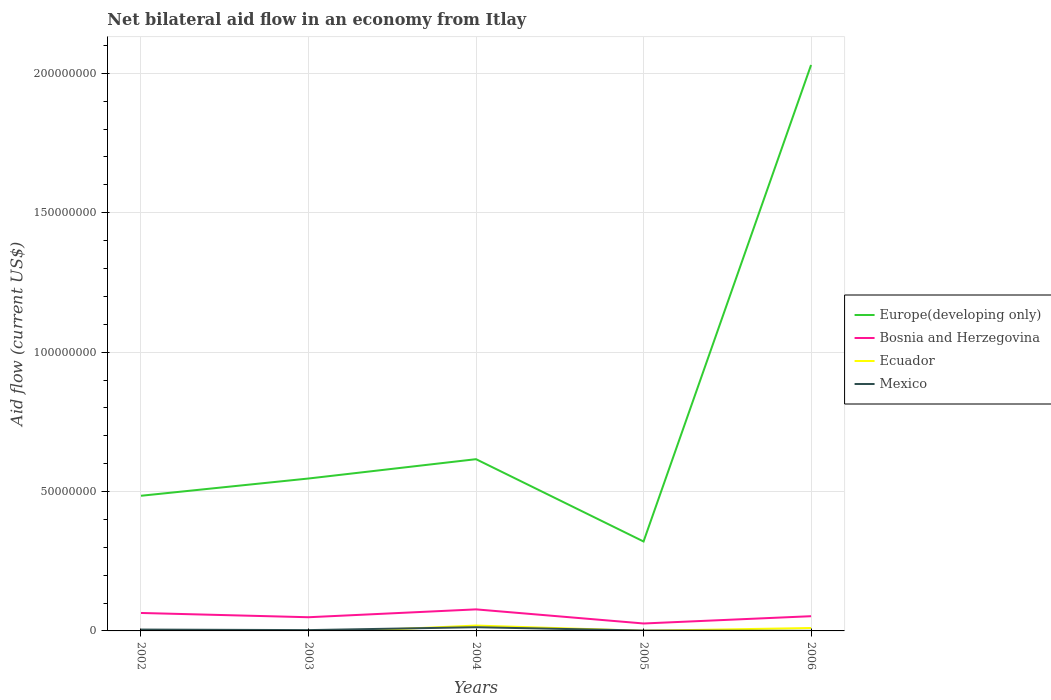How many different coloured lines are there?
Offer a terse response. 4. Is the number of lines equal to the number of legend labels?
Give a very brief answer. No. Across all years, what is the maximum net bilateral aid flow in Mexico?
Ensure brevity in your answer.  2.00e+04. What is the total net bilateral aid flow in Bosnia and Herzegovina in the graph?
Offer a very short reply. 2.24e+06. What is the difference between the highest and the second highest net bilateral aid flow in Europe(developing only)?
Ensure brevity in your answer.  1.71e+08. What is the difference between the highest and the lowest net bilateral aid flow in Bosnia and Herzegovina?
Your response must be concise. 2. Are the values on the major ticks of Y-axis written in scientific E-notation?
Give a very brief answer. No. Where does the legend appear in the graph?
Your answer should be very brief. Center right. What is the title of the graph?
Offer a terse response. Net bilateral aid flow in an economy from Itlay. Does "European Union" appear as one of the legend labels in the graph?
Make the answer very short. No. What is the Aid flow (current US$) of Europe(developing only) in 2002?
Provide a short and direct response. 4.85e+07. What is the Aid flow (current US$) in Bosnia and Herzegovina in 2002?
Keep it short and to the point. 6.44e+06. What is the Aid flow (current US$) of Ecuador in 2002?
Offer a very short reply. 3.20e+05. What is the Aid flow (current US$) of Europe(developing only) in 2003?
Keep it short and to the point. 5.47e+07. What is the Aid flow (current US$) of Bosnia and Herzegovina in 2003?
Make the answer very short. 4.91e+06. What is the Aid flow (current US$) of Ecuador in 2003?
Offer a terse response. 0. What is the Aid flow (current US$) of Europe(developing only) in 2004?
Your answer should be compact. 6.16e+07. What is the Aid flow (current US$) in Bosnia and Herzegovina in 2004?
Offer a terse response. 7.73e+06. What is the Aid flow (current US$) in Ecuador in 2004?
Offer a very short reply. 1.93e+06. What is the Aid flow (current US$) in Mexico in 2004?
Your answer should be very brief. 1.33e+06. What is the Aid flow (current US$) of Europe(developing only) in 2005?
Ensure brevity in your answer.  3.21e+07. What is the Aid flow (current US$) of Bosnia and Herzegovina in 2005?
Your answer should be very brief. 2.67e+06. What is the Aid flow (current US$) in Ecuador in 2005?
Ensure brevity in your answer.  5.00e+04. What is the Aid flow (current US$) of Europe(developing only) in 2006?
Ensure brevity in your answer.  2.03e+08. What is the Aid flow (current US$) of Bosnia and Herzegovina in 2006?
Ensure brevity in your answer.  5.28e+06. What is the Aid flow (current US$) of Ecuador in 2006?
Provide a short and direct response. 1.05e+06. What is the Aid flow (current US$) of Mexico in 2006?
Your answer should be very brief. 2.00e+04. Across all years, what is the maximum Aid flow (current US$) in Europe(developing only)?
Make the answer very short. 2.03e+08. Across all years, what is the maximum Aid flow (current US$) in Bosnia and Herzegovina?
Make the answer very short. 7.73e+06. Across all years, what is the maximum Aid flow (current US$) of Ecuador?
Offer a very short reply. 1.93e+06. Across all years, what is the maximum Aid flow (current US$) in Mexico?
Your response must be concise. 1.33e+06. Across all years, what is the minimum Aid flow (current US$) of Europe(developing only)?
Make the answer very short. 3.21e+07. Across all years, what is the minimum Aid flow (current US$) in Bosnia and Herzegovina?
Give a very brief answer. 2.67e+06. What is the total Aid flow (current US$) of Europe(developing only) in the graph?
Keep it short and to the point. 4.00e+08. What is the total Aid flow (current US$) of Bosnia and Herzegovina in the graph?
Make the answer very short. 2.70e+07. What is the total Aid flow (current US$) in Ecuador in the graph?
Keep it short and to the point. 3.35e+06. What is the total Aid flow (current US$) in Mexico in the graph?
Your answer should be very brief. 2.27e+06. What is the difference between the Aid flow (current US$) of Europe(developing only) in 2002 and that in 2003?
Keep it short and to the point. -6.19e+06. What is the difference between the Aid flow (current US$) of Bosnia and Herzegovina in 2002 and that in 2003?
Provide a short and direct response. 1.53e+06. What is the difference between the Aid flow (current US$) in Europe(developing only) in 2002 and that in 2004?
Your response must be concise. -1.31e+07. What is the difference between the Aid flow (current US$) of Bosnia and Herzegovina in 2002 and that in 2004?
Offer a very short reply. -1.29e+06. What is the difference between the Aid flow (current US$) in Ecuador in 2002 and that in 2004?
Your answer should be very brief. -1.61e+06. What is the difference between the Aid flow (current US$) in Mexico in 2002 and that in 2004?
Give a very brief answer. -8.40e+05. What is the difference between the Aid flow (current US$) in Europe(developing only) in 2002 and that in 2005?
Offer a very short reply. 1.64e+07. What is the difference between the Aid flow (current US$) of Bosnia and Herzegovina in 2002 and that in 2005?
Your answer should be very brief. 3.77e+06. What is the difference between the Aid flow (current US$) of Mexico in 2002 and that in 2005?
Your answer should be very brief. 3.50e+05. What is the difference between the Aid flow (current US$) of Europe(developing only) in 2002 and that in 2006?
Ensure brevity in your answer.  -1.55e+08. What is the difference between the Aid flow (current US$) of Bosnia and Herzegovina in 2002 and that in 2006?
Offer a very short reply. 1.16e+06. What is the difference between the Aid flow (current US$) in Ecuador in 2002 and that in 2006?
Make the answer very short. -7.30e+05. What is the difference between the Aid flow (current US$) of Mexico in 2002 and that in 2006?
Your answer should be compact. 4.70e+05. What is the difference between the Aid flow (current US$) in Europe(developing only) in 2003 and that in 2004?
Provide a succinct answer. -6.93e+06. What is the difference between the Aid flow (current US$) in Bosnia and Herzegovina in 2003 and that in 2004?
Provide a short and direct response. -2.82e+06. What is the difference between the Aid flow (current US$) in Mexico in 2003 and that in 2004?
Keep it short and to the point. -1.04e+06. What is the difference between the Aid flow (current US$) of Europe(developing only) in 2003 and that in 2005?
Provide a short and direct response. 2.26e+07. What is the difference between the Aid flow (current US$) in Bosnia and Herzegovina in 2003 and that in 2005?
Offer a terse response. 2.24e+06. What is the difference between the Aid flow (current US$) of Mexico in 2003 and that in 2005?
Keep it short and to the point. 1.50e+05. What is the difference between the Aid flow (current US$) in Europe(developing only) in 2003 and that in 2006?
Offer a terse response. -1.48e+08. What is the difference between the Aid flow (current US$) in Bosnia and Herzegovina in 2003 and that in 2006?
Give a very brief answer. -3.70e+05. What is the difference between the Aid flow (current US$) of Europe(developing only) in 2004 and that in 2005?
Offer a terse response. 2.95e+07. What is the difference between the Aid flow (current US$) in Bosnia and Herzegovina in 2004 and that in 2005?
Give a very brief answer. 5.06e+06. What is the difference between the Aid flow (current US$) in Ecuador in 2004 and that in 2005?
Your response must be concise. 1.88e+06. What is the difference between the Aid flow (current US$) of Mexico in 2004 and that in 2005?
Your answer should be very brief. 1.19e+06. What is the difference between the Aid flow (current US$) of Europe(developing only) in 2004 and that in 2006?
Your answer should be compact. -1.41e+08. What is the difference between the Aid flow (current US$) of Bosnia and Herzegovina in 2004 and that in 2006?
Make the answer very short. 2.45e+06. What is the difference between the Aid flow (current US$) of Ecuador in 2004 and that in 2006?
Your answer should be compact. 8.80e+05. What is the difference between the Aid flow (current US$) in Mexico in 2004 and that in 2006?
Your response must be concise. 1.31e+06. What is the difference between the Aid flow (current US$) of Europe(developing only) in 2005 and that in 2006?
Your answer should be compact. -1.71e+08. What is the difference between the Aid flow (current US$) of Bosnia and Herzegovina in 2005 and that in 2006?
Provide a succinct answer. -2.61e+06. What is the difference between the Aid flow (current US$) in Europe(developing only) in 2002 and the Aid flow (current US$) in Bosnia and Herzegovina in 2003?
Ensure brevity in your answer.  4.36e+07. What is the difference between the Aid flow (current US$) of Europe(developing only) in 2002 and the Aid flow (current US$) of Mexico in 2003?
Offer a very short reply. 4.82e+07. What is the difference between the Aid flow (current US$) in Bosnia and Herzegovina in 2002 and the Aid flow (current US$) in Mexico in 2003?
Offer a very short reply. 6.15e+06. What is the difference between the Aid flow (current US$) in Ecuador in 2002 and the Aid flow (current US$) in Mexico in 2003?
Offer a very short reply. 3.00e+04. What is the difference between the Aid flow (current US$) of Europe(developing only) in 2002 and the Aid flow (current US$) of Bosnia and Herzegovina in 2004?
Provide a short and direct response. 4.08e+07. What is the difference between the Aid flow (current US$) in Europe(developing only) in 2002 and the Aid flow (current US$) in Ecuador in 2004?
Ensure brevity in your answer.  4.66e+07. What is the difference between the Aid flow (current US$) in Europe(developing only) in 2002 and the Aid flow (current US$) in Mexico in 2004?
Your response must be concise. 4.72e+07. What is the difference between the Aid flow (current US$) in Bosnia and Herzegovina in 2002 and the Aid flow (current US$) in Ecuador in 2004?
Offer a terse response. 4.51e+06. What is the difference between the Aid flow (current US$) of Bosnia and Herzegovina in 2002 and the Aid flow (current US$) of Mexico in 2004?
Your answer should be very brief. 5.11e+06. What is the difference between the Aid flow (current US$) of Ecuador in 2002 and the Aid flow (current US$) of Mexico in 2004?
Provide a short and direct response. -1.01e+06. What is the difference between the Aid flow (current US$) of Europe(developing only) in 2002 and the Aid flow (current US$) of Bosnia and Herzegovina in 2005?
Give a very brief answer. 4.58e+07. What is the difference between the Aid flow (current US$) in Europe(developing only) in 2002 and the Aid flow (current US$) in Ecuador in 2005?
Make the answer very short. 4.84e+07. What is the difference between the Aid flow (current US$) of Europe(developing only) in 2002 and the Aid flow (current US$) of Mexico in 2005?
Provide a short and direct response. 4.83e+07. What is the difference between the Aid flow (current US$) in Bosnia and Herzegovina in 2002 and the Aid flow (current US$) in Ecuador in 2005?
Your response must be concise. 6.39e+06. What is the difference between the Aid flow (current US$) in Bosnia and Herzegovina in 2002 and the Aid flow (current US$) in Mexico in 2005?
Ensure brevity in your answer.  6.30e+06. What is the difference between the Aid flow (current US$) of Europe(developing only) in 2002 and the Aid flow (current US$) of Bosnia and Herzegovina in 2006?
Your answer should be compact. 4.32e+07. What is the difference between the Aid flow (current US$) in Europe(developing only) in 2002 and the Aid flow (current US$) in Ecuador in 2006?
Offer a very short reply. 4.74e+07. What is the difference between the Aid flow (current US$) in Europe(developing only) in 2002 and the Aid flow (current US$) in Mexico in 2006?
Offer a very short reply. 4.85e+07. What is the difference between the Aid flow (current US$) of Bosnia and Herzegovina in 2002 and the Aid flow (current US$) of Ecuador in 2006?
Offer a very short reply. 5.39e+06. What is the difference between the Aid flow (current US$) in Bosnia and Herzegovina in 2002 and the Aid flow (current US$) in Mexico in 2006?
Make the answer very short. 6.42e+06. What is the difference between the Aid flow (current US$) in Ecuador in 2002 and the Aid flow (current US$) in Mexico in 2006?
Ensure brevity in your answer.  3.00e+05. What is the difference between the Aid flow (current US$) in Europe(developing only) in 2003 and the Aid flow (current US$) in Bosnia and Herzegovina in 2004?
Make the answer very short. 4.69e+07. What is the difference between the Aid flow (current US$) of Europe(developing only) in 2003 and the Aid flow (current US$) of Ecuador in 2004?
Offer a very short reply. 5.27e+07. What is the difference between the Aid flow (current US$) of Europe(developing only) in 2003 and the Aid flow (current US$) of Mexico in 2004?
Provide a short and direct response. 5.33e+07. What is the difference between the Aid flow (current US$) of Bosnia and Herzegovina in 2003 and the Aid flow (current US$) of Ecuador in 2004?
Provide a succinct answer. 2.98e+06. What is the difference between the Aid flow (current US$) of Bosnia and Herzegovina in 2003 and the Aid flow (current US$) of Mexico in 2004?
Ensure brevity in your answer.  3.58e+06. What is the difference between the Aid flow (current US$) of Europe(developing only) in 2003 and the Aid flow (current US$) of Bosnia and Herzegovina in 2005?
Ensure brevity in your answer.  5.20e+07. What is the difference between the Aid flow (current US$) of Europe(developing only) in 2003 and the Aid flow (current US$) of Ecuador in 2005?
Your response must be concise. 5.46e+07. What is the difference between the Aid flow (current US$) in Europe(developing only) in 2003 and the Aid flow (current US$) in Mexico in 2005?
Provide a short and direct response. 5.45e+07. What is the difference between the Aid flow (current US$) in Bosnia and Herzegovina in 2003 and the Aid flow (current US$) in Ecuador in 2005?
Provide a succinct answer. 4.86e+06. What is the difference between the Aid flow (current US$) in Bosnia and Herzegovina in 2003 and the Aid flow (current US$) in Mexico in 2005?
Keep it short and to the point. 4.77e+06. What is the difference between the Aid flow (current US$) in Europe(developing only) in 2003 and the Aid flow (current US$) in Bosnia and Herzegovina in 2006?
Keep it short and to the point. 4.94e+07. What is the difference between the Aid flow (current US$) in Europe(developing only) in 2003 and the Aid flow (current US$) in Ecuador in 2006?
Your answer should be compact. 5.36e+07. What is the difference between the Aid flow (current US$) in Europe(developing only) in 2003 and the Aid flow (current US$) in Mexico in 2006?
Provide a succinct answer. 5.46e+07. What is the difference between the Aid flow (current US$) of Bosnia and Herzegovina in 2003 and the Aid flow (current US$) of Ecuador in 2006?
Offer a very short reply. 3.86e+06. What is the difference between the Aid flow (current US$) in Bosnia and Herzegovina in 2003 and the Aid flow (current US$) in Mexico in 2006?
Your answer should be very brief. 4.89e+06. What is the difference between the Aid flow (current US$) of Europe(developing only) in 2004 and the Aid flow (current US$) of Bosnia and Herzegovina in 2005?
Offer a very short reply. 5.89e+07. What is the difference between the Aid flow (current US$) of Europe(developing only) in 2004 and the Aid flow (current US$) of Ecuador in 2005?
Ensure brevity in your answer.  6.16e+07. What is the difference between the Aid flow (current US$) of Europe(developing only) in 2004 and the Aid flow (current US$) of Mexico in 2005?
Make the answer very short. 6.15e+07. What is the difference between the Aid flow (current US$) of Bosnia and Herzegovina in 2004 and the Aid flow (current US$) of Ecuador in 2005?
Keep it short and to the point. 7.68e+06. What is the difference between the Aid flow (current US$) of Bosnia and Herzegovina in 2004 and the Aid flow (current US$) of Mexico in 2005?
Make the answer very short. 7.59e+06. What is the difference between the Aid flow (current US$) of Ecuador in 2004 and the Aid flow (current US$) of Mexico in 2005?
Ensure brevity in your answer.  1.79e+06. What is the difference between the Aid flow (current US$) in Europe(developing only) in 2004 and the Aid flow (current US$) in Bosnia and Herzegovina in 2006?
Offer a terse response. 5.63e+07. What is the difference between the Aid flow (current US$) in Europe(developing only) in 2004 and the Aid flow (current US$) in Ecuador in 2006?
Make the answer very short. 6.06e+07. What is the difference between the Aid flow (current US$) of Europe(developing only) in 2004 and the Aid flow (current US$) of Mexico in 2006?
Ensure brevity in your answer.  6.16e+07. What is the difference between the Aid flow (current US$) of Bosnia and Herzegovina in 2004 and the Aid flow (current US$) of Ecuador in 2006?
Offer a terse response. 6.68e+06. What is the difference between the Aid flow (current US$) of Bosnia and Herzegovina in 2004 and the Aid flow (current US$) of Mexico in 2006?
Give a very brief answer. 7.71e+06. What is the difference between the Aid flow (current US$) of Ecuador in 2004 and the Aid flow (current US$) of Mexico in 2006?
Offer a very short reply. 1.91e+06. What is the difference between the Aid flow (current US$) in Europe(developing only) in 2005 and the Aid flow (current US$) in Bosnia and Herzegovina in 2006?
Give a very brief answer. 2.68e+07. What is the difference between the Aid flow (current US$) of Europe(developing only) in 2005 and the Aid flow (current US$) of Ecuador in 2006?
Make the answer very short. 3.10e+07. What is the difference between the Aid flow (current US$) in Europe(developing only) in 2005 and the Aid flow (current US$) in Mexico in 2006?
Your response must be concise. 3.21e+07. What is the difference between the Aid flow (current US$) of Bosnia and Herzegovina in 2005 and the Aid flow (current US$) of Ecuador in 2006?
Provide a short and direct response. 1.62e+06. What is the difference between the Aid flow (current US$) of Bosnia and Herzegovina in 2005 and the Aid flow (current US$) of Mexico in 2006?
Your response must be concise. 2.65e+06. What is the difference between the Aid flow (current US$) in Ecuador in 2005 and the Aid flow (current US$) in Mexico in 2006?
Keep it short and to the point. 3.00e+04. What is the average Aid flow (current US$) of Europe(developing only) per year?
Keep it short and to the point. 8.00e+07. What is the average Aid flow (current US$) of Bosnia and Herzegovina per year?
Your response must be concise. 5.41e+06. What is the average Aid flow (current US$) in Ecuador per year?
Your response must be concise. 6.70e+05. What is the average Aid flow (current US$) in Mexico per year?
Provide a short and direct response. 4.54e+05. In the year 2002, what is the difference between the Aid flow (current US$) of Europe(developing only) and Aid flow (current US$) of Bosnia and Herzegovina?
Ensure brevity in your answer.  4.20e+07. In the year 2002, what is the difference between the Aid flow (current US$) of Europe(developing only) and Aid flow (current US$) of Ecuador?
Provide a succinct answer. 4.82e+07. In the year 2002, what is the difference between the Aid flow (current US$) in Europe(developing only) and Aid flow (current US$) in Mexico?
Offer a terse response. 4.80e+07. In the year 2002, what is the difference between the Aid flow (current US$) of Bosnia and Herzegovina and Aid flow (current US$) of Ecuador?
Offer a terse response. 6.12e+06. In the year 2002, what is the difference between the Aid flow (current US$) of Bosnia and Herzegovina and Aid flow (current US$) of Mexico?
Give a very brief answer. 5.95e+06. In the year 2003, what is the difference between the Aid flow (current US$) of Europe(developing only) and Aid flow (current US$) of Bosnia and Herzegovina?
Provide a succinct answer. 4.98e+07. In the year 2003, what is the difference between the Aid flow (current US$) of Europe(developing only) and Aid flow (current US$) of Mexico?
Make the answer very short. 5.44e+07. In the year 2003, what is the difference between the Aid flow (current US$) of Bosnia and Herzegovina and Aid flow (current US$) of Mexico?
Provide a succinct answer. 4.62e+06. In the year 2004, what is the difference between the Aid flow (current US$) in Europe(developing only) and Aid flow (current US$) in Bosnia and Herzegovina?
Keep it short and to the point. 5.39e+07. In the year 2004, what is the difference between the Aid flow (current US$) of Europe(developing only) and Aid flow (current US$) of Ecuador?
Provide a short and direct response. 5.97e+07. In the year 2004, what is the difference between the Aid flow (current US$) in Europe(developing only) and Aid flow (current US$) in Mexico?
Your response must be concise. 6.03e+07. In the year 2004, what is the difference between the Aid flow (current US$) of Bosnia and Herzegovina and Aid flow (current US$) of Ecuador?
Offer a very short reply. 5.80e+06. In the year 2004, what is the difference between the Aid flow (current US$) of Bosnia and Herzegovina and Aid flow (current US$) of Mexico?
Your answer should be compact. 6.40e+06. In the year 2005, what is the difference between the Aid flow (current US$) of Europe(developing only) and Aid flow (current US$) of Bosnia and Herzegovina?
Provide a short and direct response. 2.94e+07. In the year 2005, what is the difference between the Aid flow (current US$) of Europe(developing only) and Aid flow (current US$) of Ecuador?
Provide a succinct answer. 3.20e+07. In the year 2005, what is the difference between the Aid flow (current US$) in Europe(developing only) and Aid flow (current US$) in Mexico?
Provide a succinct answer. 3.19e+07. In the year 2005, what is the difference between the Aid flow (current US$) in Bosnia and Herzegovina and Aid flow (current US$) in Ecuador?
Your answer should be very brief. 2.62e+06. In the year 2005, what is the difference between the Aid flow (current US$) in Bosnia and Herzegovina and Aid flow (current US$) in Mexico?
Provide a short and direct response. 2.53e+06. In the year 2006, what is the difference between the Aid flow (current US$) in Europe(developing only) and Aid flow (current US$) in Bosnia and Herzegovina?
Offer a terse response. 1.98e+08. In the year 2006, what is the difference between the Aid flow (current US$) in Europe(developing only) and Aid flow (current US$) in Ecuador?
Make the answer very short. 2.02e+08. In the year 2006, what is the difference between the Aid flow (current US$) in Europe(developing only) and Aid flow (current US$) in Mexico?
Give a very brief answer. 2.03e+08. In the year 2006, what is the difference between the Aid flow (current US$) of Bosnia and Herzegovina and Aid flow (current US$) of Ecuador?
Offer a very short reply. 4.23e+06. In the year 2006, what is the difference between the Aid flow (current US$) of Bosnia and Herzegovina and Aid flow (current US$) of Mexico?
Offer a very short reply. 5.26e+06. In the year 2006, what is the difference between the Aid flow (current US$) in Ecuador and Aid flow (current US$) in Mexico?
Your answer should be compact. 1.03e+06. What is the ratio of the Aid flow (current US$) of Europe(developing only) in 2002 to that in 2003?
Ensure brevity in your answer.  0.89. What is the ratio of the Aid flow (current US$) in Bosnia and Herzegovina in 2002 to that in 2003?
Keep it short and to the point. 1.31. What is the ratio of the Aid flow (current US$) of Mexico in 2002 to that in 2003?
Provide a short and direct response. 1.69. What is the ratio of the Aid flow (current US$) in Europe(developing only) in 2002 to that in 2004?
Ensure brevity in your answer.  0.79. What is the ratio of the Aid flow (current US$) in Bosnia and Herzegovina in 2002 to that in 2004?
Your answer should be compact. 0.83. What is the ratio of the Aid flow (current US$) of Ecuador in 2002 to that in 2004?
Ensure brevity in your answer.  0.17. What is the ratio of the Aid flow (current US$) in Mexico in 2002 to that in 2004?
Your answer should be compact. 0.37. What is the ratio of the Aid flow (current US$) in Europe(developing only) in 2002 to that in 2005?
Ensure brevity in your answer.  1.51. What is the ratio of the Aid flow (current US$) in Bosnia and Herzegovina in 2002 to that in 2005?
Keep it short and to the point. 2.41. What is the ratio of the Aid flow (current US$) in Europe(developing only) in 2002 to that in 2006?
Provide a short and direct response. 0.24. What is the ratio of the Aid flow (current US$) in Bosnia and Herzegovina in 2002 to that in 2006?
Give a very brief answer. 1.22. What is the ratio of the Aid flow (current US$) of Ecuador in 2002 to that in 2006?
Your answer should be very brief. 0.3. What is the ratio of the Aid flow (current US$) in Europe(developing only) in 2003 to that in 2004?
Offer a terse response. 0.89. What is the ratio of the Aid flow (current US$) of Bosnia and Herzegovina in 2003 to that in 2004?
Your answer should be very brief. 0.64. What is the ratio of the Aid flow (current US$) in Mexico in 2003 to that in 2004?
Your answer should be compact. 0.22. What is the ratio of the Aid flow (current US$) in Europe(developing only) in 2003 to that in 2005?
Your answer should be very brief. 1.7. What is the ratio of the Aid flow (current US$) in Bosnia and Herzegovina in 2003 to that in 2005?
Make the answer very short. 1.84. What is the ratio of the Aid flow (current US$) in Mexico in 2003 to that in 2005?
Ensure brevity in your answer.  2.07. What is the ratio of the Aid flow (current US$) of Europe(developing only) in 2003 to that in 2006?
Your answer should be compact. 0.27. What is the ratio of the Aid flow (current US$) of Bosnia and Herzegovina in 2003 to that in 2006?
Offer a very short reply. 0.93. What is the ratio of the Aid flow (current US$) in Mexico in 2003 to that in 2006?
Your answer should be compact. 14.5. What is the ratio of the Aid flow (current US$) of Europe(developing only) in 2004 to that in 2005?
Give a very brief answer. 1.92. What is the ratio of the Aid flow (current US$) in Bosnia and Herzegovina in 2004 to that in 2005?
Give a very brief answer. 2.9. What is the ratio of the Aid flow (current US$) in Ecuador in 2004 to that in 2005?
Your response must be concise. 38.6. What is the ratio of the Aid flow (current US$) of Mexico in 2004 to that in 2005?
Make the answer very short. 9.5. What is the ratio of the Aid flow (current US$) in Europe(developing only) in 2004 to that in 2006?
Provide a short and direct response. 0.3. What is the ratio of the Aid flow (current US$) in Bosnia and Herzegovina in 2004 to that in 2006?
Offer a terse response. 1.46. What is the ratio of the Aid flow (current US$) of Ecuador in 2004 to that in 2006?
Offer a very short reply. 1.84. What is the ratio of the Aid flow (current US$) in Mexico in 2004 to that in 2006?
Your response must be concise. 66.5. What is the ratio of the Aid flow (current US$) of Europe(developing only) in 2005 to that in 2006?
Provide a succinct answer. 0.16. What is the ratio of the Aid flow (current US$) of Bosnia and Herzegovina in 2005 to that in 2006?
Give a very brief answer. 0.51. What is the ratio of the Aid flow (current US$) of Ecuador in 2005 to that in 2006?
Your response must be concise. 0.05. What is the difference between the highest and the second highest Aid flow (current US$) in Europe(developing only)?
Offer a terse response. 1.41e+08. What is the difference between the highest and the second highest Aid flow (current US$) in Bosnia and Herzegovina?
Offer a terse response. 1.29e+06. What is the difference between the highest and the second highest Aid flow (current US$) in Ecuador?
Provide a succinct answer. 8.80e+05. What is the difference between the highest and the second highest Aid flow (current US$) in Mexico?
Offer a very short reply. 8.40e+05. What is the difference between the highest and the lowest Aid flow (current US$) of Europe(developing only)?
Offer a very short reply. 1.71e+08. What is the difference between the highest and the lowest Aid flow (current US$) of Bosnia and Herzegovina?
Your response must be concise. 5.06e+06. What is the difference between the highest and the lowest Aid flow (current US$) in Ecuador?
Your answer should be compact. 1.93e+06. What is the difference between the highest and the lowest Aid flow (current US$) of Mexico?
Offer a very short reply. 1.31e+06. 